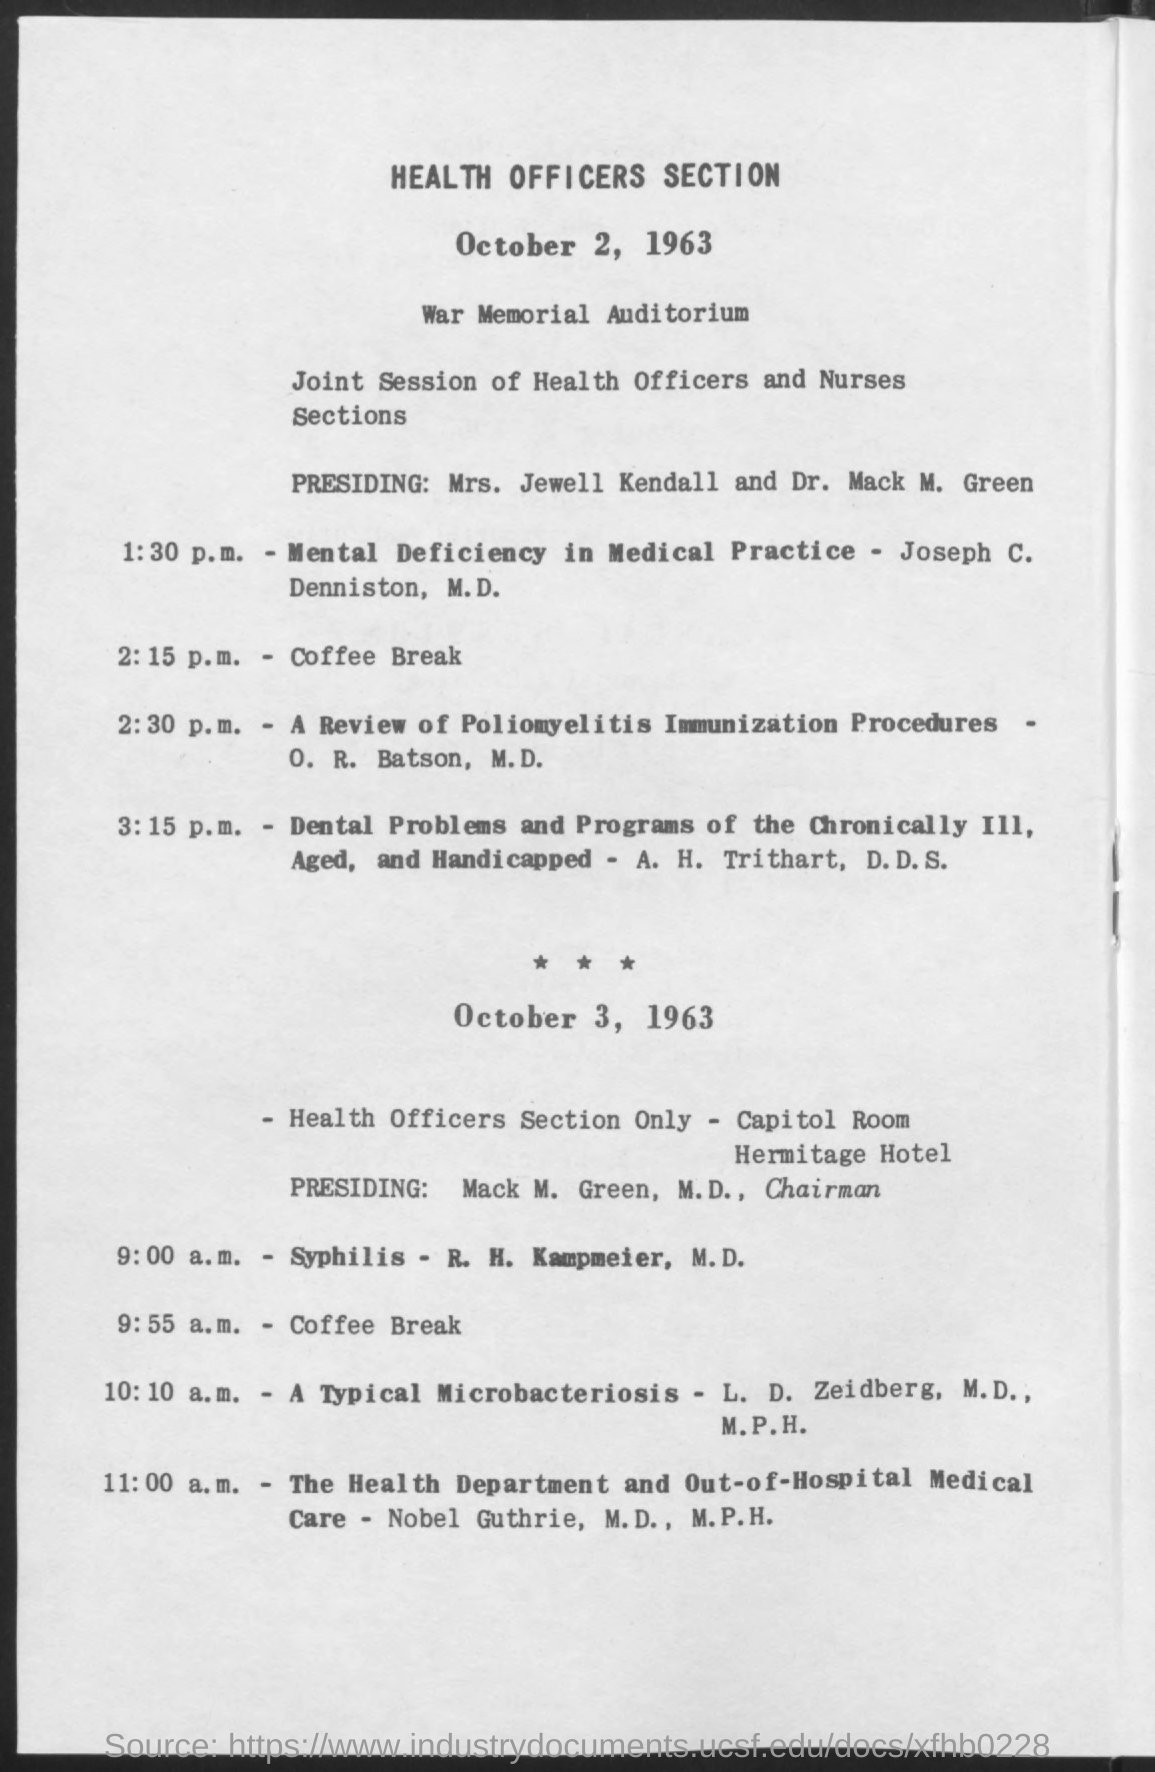Where is it held?
Ensure brevity in your answer.  War memorial auditorium. When is the coffee break on October 2, 1963?
Make the answer very short. 2:15 p.m. Who is presiding on October 3, 1963?
Your answer should be very brief. Mack m. green. 